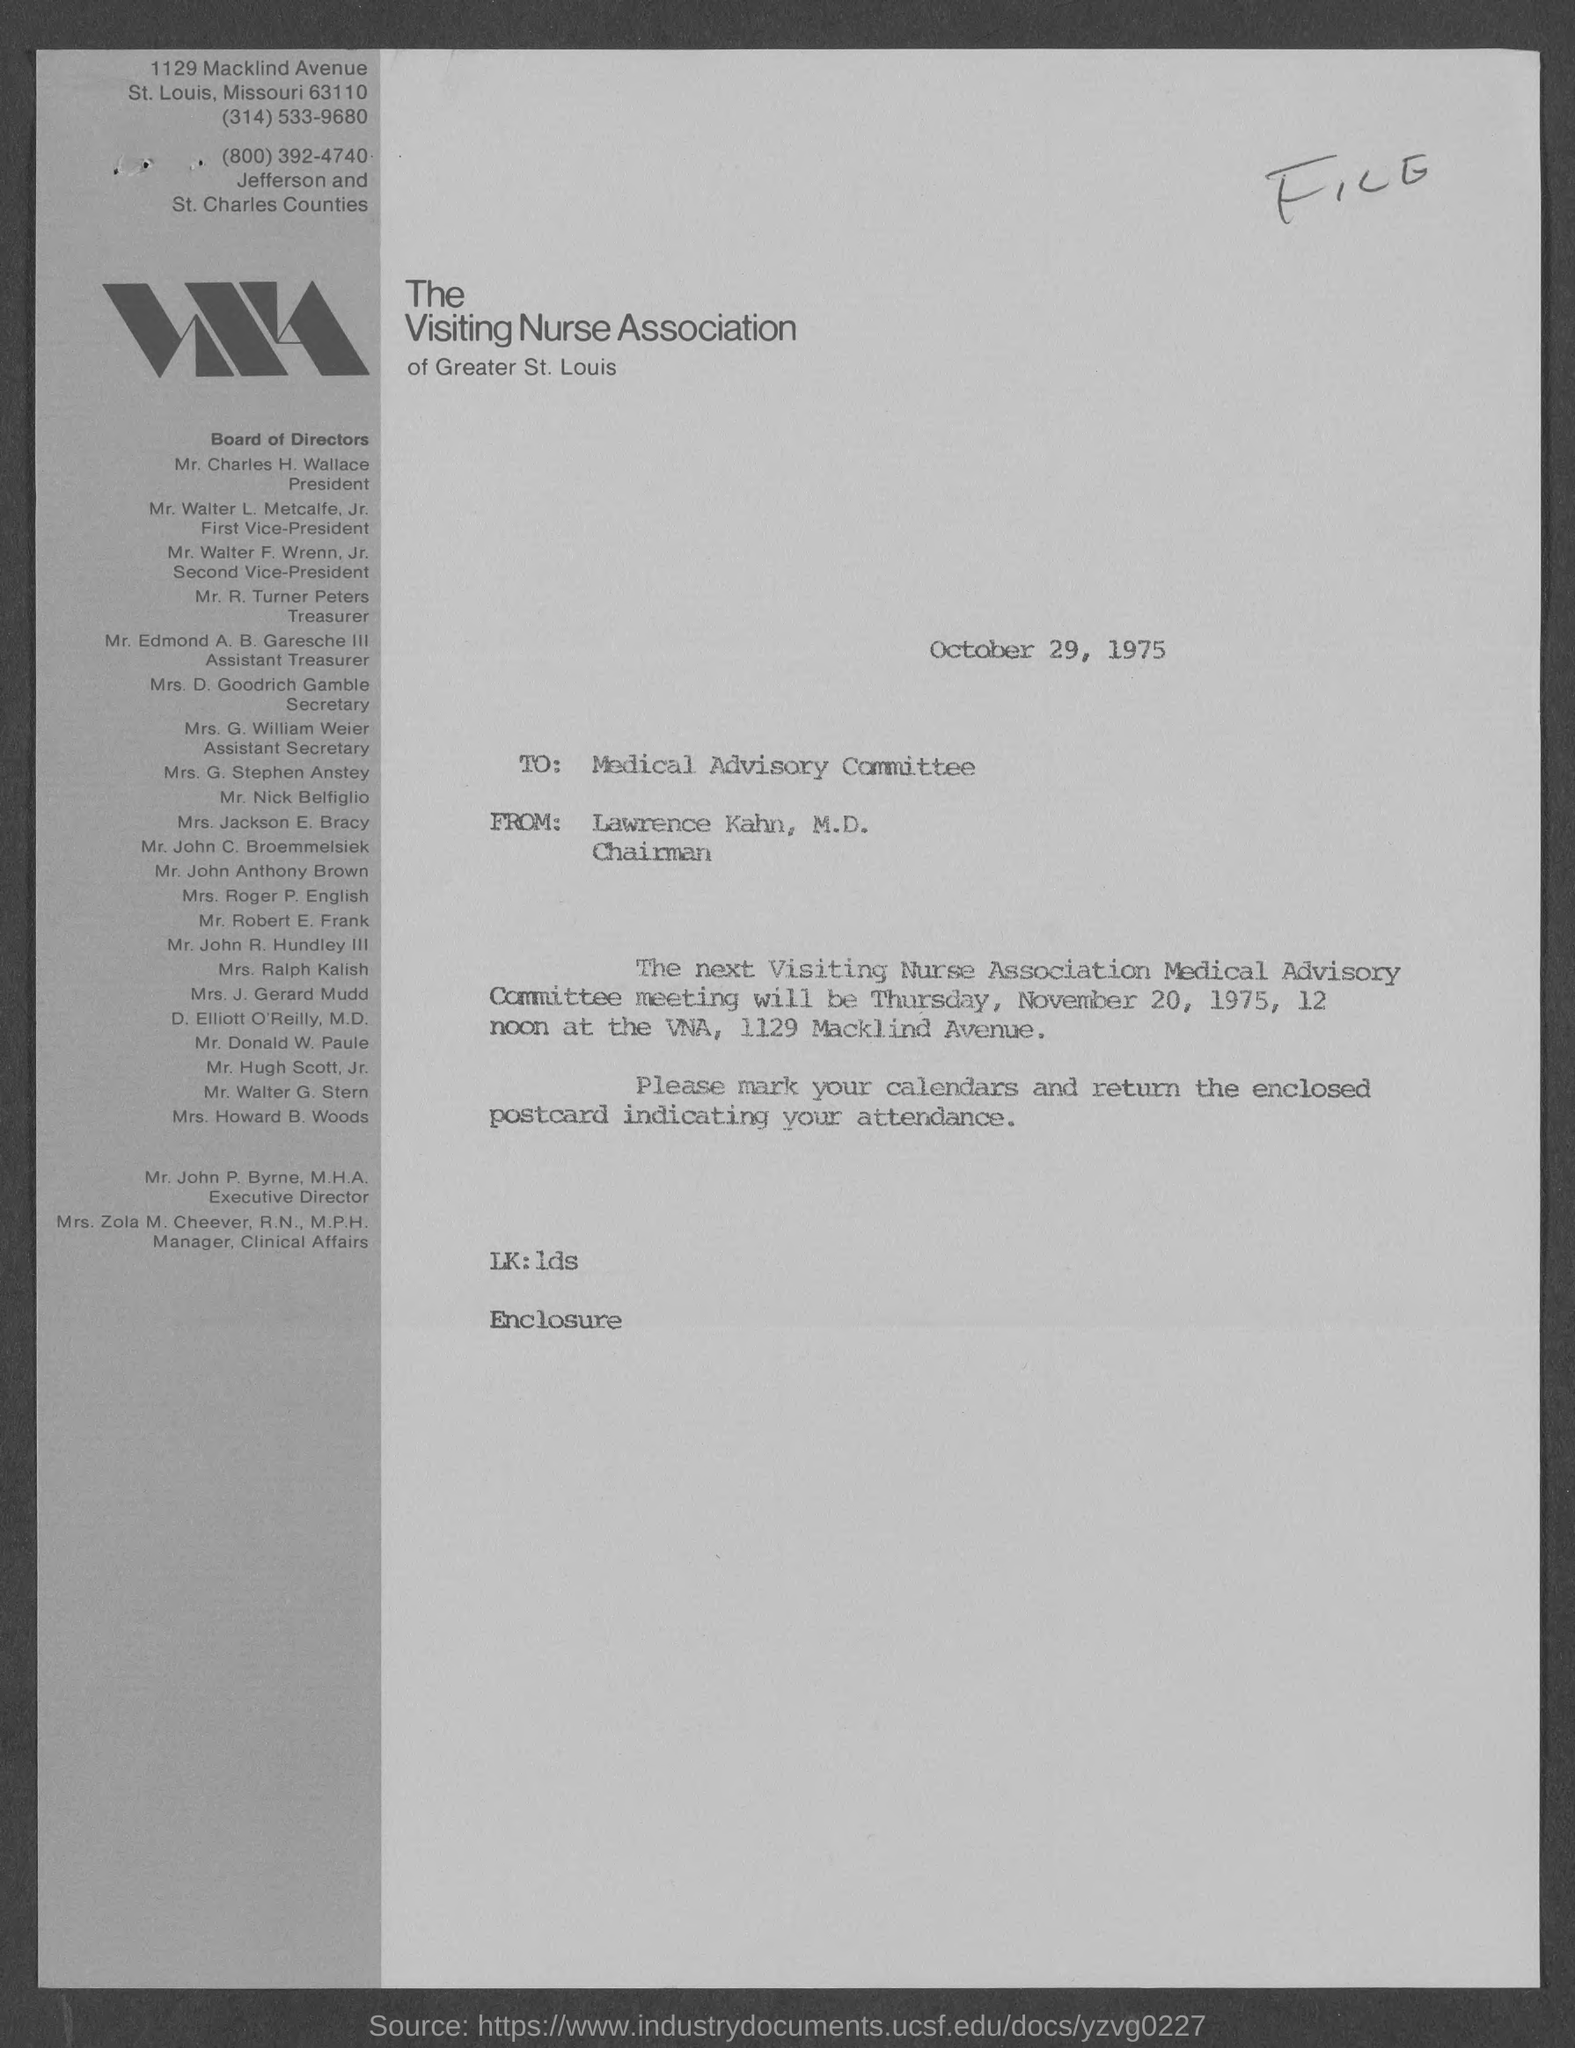What is the position of mr. charles h. wallace ?
Offer a terse response. President. What is the position of mr. walter  l. metcalfe, jr.?
Make the answer very short. First Vice- President. What is the position of mr. walter f. wrenn, jr ?
Your answer should be very brief. Second vice president. What is the position of mr. r. turner peters ?
Ensure brevity in your answer.  Treasurer. What is the position of mr. edmond a. b. garesche iii ?
Offer a very short reply. Assistant Treasurer. What is the position of mrs. d. goodrich gamble ?
Ensure brevity in your answer.  Secretary. What is the position of mrs. g. william weier ?
Provide a short and direct response. Assistant Secretary. When is the memorandum dated?
Offer a terse response. October 29, 1975. What is from address in memorandum ?
Keep it short and to the point. Lawrence kahn, m.d. 